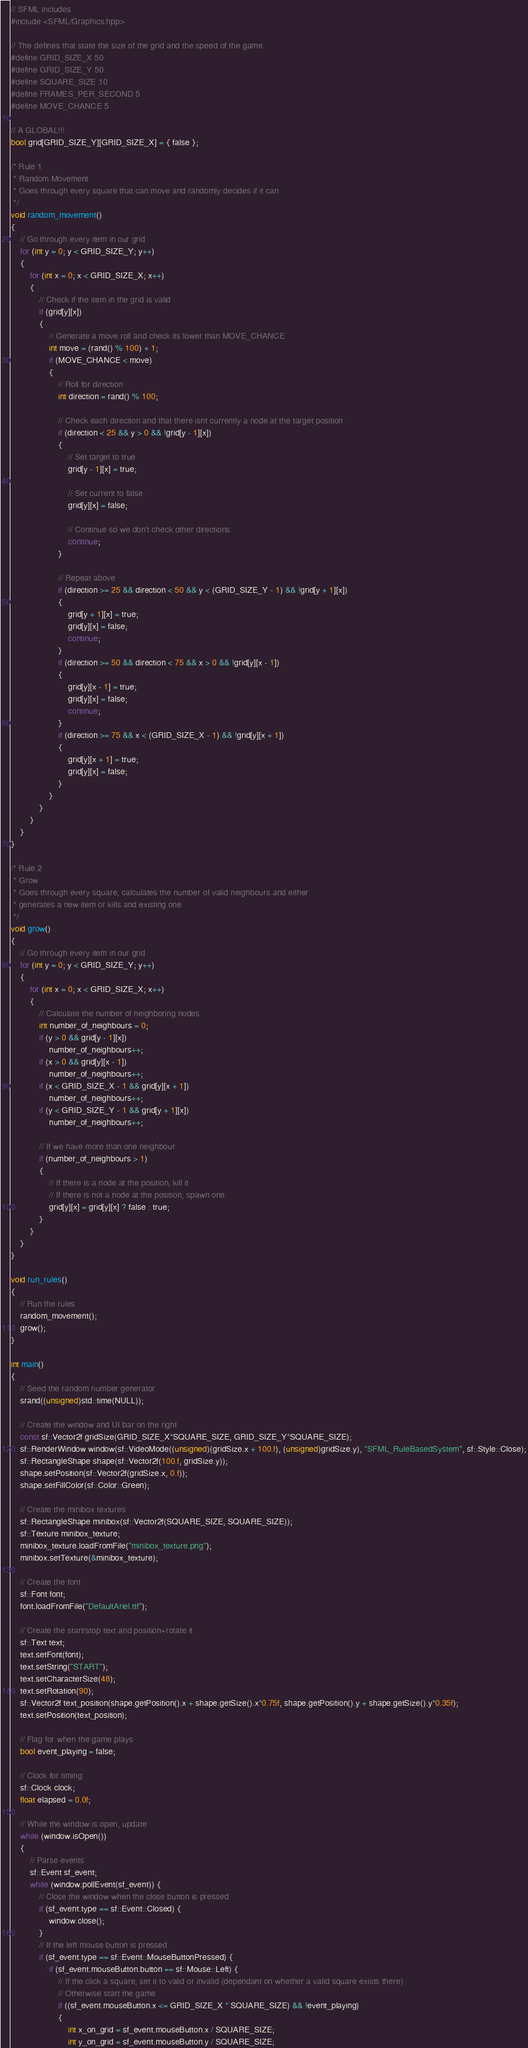Convert code to text. <code><loc_0><loc_0><loc_500><loc_500><_C++_>// SFML includes
#include <SFML/Graphics.hpp>

// The defines that state the size of the grid and the speed of the game.
#define GRID_SIZE_X 50
#define GRID_SIZE_Y 50
#define SQUARE_SIZE 10
#define FRAMES_PER_SECOND 5
#define MOVE_CHANCE 5

// A GLOBAL!!! 
bool grid[GRID_SIZE_Y][GRID_SIZE_X] = { false };

/* Rule 1
 * Random Movement
 * Goes through every square that can move and randomly decides if it can
 */
void random_movement()
{
	// Go through every item in our grid
	for (int y = 0; y < GRID_SIZE_Y; y++)
	{
		for (int x = 0; x < GRID_SIZE_X; x++)
		{
			// Check if the item in the grid is valid
			if (grid[y][x])
			{
				// Generate a move roll and check its lower than MOVE_CHANCE
				int move = (rand() % 100) + 1;
				if (MOVE_CHANCE < move)
				{
					// Roll for direction
					int direction = rand() % 100;

					// Check each direction and that there isnt currently a node at the target position
					if (direction < 25 && y > 0 && !grid[y - 1][x])
					{
						// Set target to true
						grid[y - 1][x] = true;

						// Set current to false
						grid[y][x] = false;

						// Continue so we don't check other directions
						continue;
					}

					// Repeat above
					if (direction >= 25 && direction < 50 && y < (GRID_SIZE_Y - 1) && !grid[y + 1][x])
					{
						grid[y + 1][x] = true;
						grid[y][x] = false;
						continue;
					}
					if (direction >= 50 && direction < 75 && x > 0 && !grid[y][x - 1])
					{
						grid[y][x - 1] = true;
						grid[y][x] = false;
						continue;
					}
					if (direction >= 75 && x < (GRID_SIZE_X - 1) && !grid[y][x + 1])
					{
						grid[y][x + 1] = true;
						grid[y][x] = false;
					}
				}
			}
		}
	}
}

/* Rule 2
 * Grow
 * Goes through every square, calculates the number of valid neighbours and either
 * generates a new item or kills and existing one
 */
void grow()
{
	// Go through every item in our grid
	for (int y = 0; y < GRID_SIZE_Y; y++)
	{
		for (int x = 0; x < GRID_SIZE_X; x++)
		{
			// Calculate the number of neighboring nodes
			int number_of_neighbours = 0;
			if (y > 0 && grid[y - 1][x])
				number_of_neighbours++;
			if (x > 0 && grid[y][x - 1])
				number_of_neighbours++;
			if (x < GRID_SIZE_X - 1 && grid[y][x + 1])
				number_of_neighbours++;
			if (y < GRID_SIZE_Y - 1 && grid[y + 1][x])
				number_of_neighbours++;

			// If we have more than one neighbour
			if (number_of_neighbours > 1)
			{
				// If there is a node at the position, kill it
				// If there is not a node at the position, spawn one
				grid[y][x] = grid[y][x] ? false : true;
			}
		}
	}
}

void run_rules()
{
	// Run the rules
	random_movement();
	grow();
}

int main()
{
	// Seed the random number generator
	srand((unsigned)std::time(NULL));

	// Create the window and UI bar on the right
	const sf::Vector2f gridSize(GRID_SIZE_X*SQUARE_SIZE, GRID_SIZE_Y*SQUARE_SIZE);
	sf::RenderWindow window(sf::VideoMode((unsigned)(gridSize.x + 100.f), (unsigned)gridSize.y), "SFML_RuleBasedSystem", sf::Style::Close);
	sf::RectangleShape shape(sf::Vector2f(100.f, gridSize.y));
	shape.setPosition(sf::Vector2f(gridSize.x, 0.f));
	shape.setFillColor(sf::Color::Green);

	// Create the minibox textures
	sf::RectangleShape minibox(sf::Vector2f(SQUARE_SIZE, SQUARE_SIZE));
	sf::Texture minibox_texture;
	minibox_texture.loadFromFile("minibox_texture.png");
	minibox.setTexture(&minibox_texture);

	// Create the font
	sf::Font font;
	font.loadFromFile("DefaultAriel.ttf");

	// Create the start/stop text and position+rotate it
	sf::Text text;
	text.setFont(font);
	text.setString("START");
	text.setCharacterSize(48);
	text.setRotation(90);
	sf::Vector2f text_position(shape.getPosition().x + shape.getSize().x*0.75f, shape.getPosition().y + shape.getSize().y*0.35f);
	text.setPosition(text_position);

	// Flag for when the game plays
	bool event_playing = false;

	// Clock for timing
	sf::Clock clock;
	float elapsed = 0.0f;

	// While the window is open, update
	while (window.isOpen())
	{
		// Parse events
		sf::Event sf_event;
		while (window.pollEvent(sf_event)) {
			// Close the window when the close button is pressed
			if (sf_event.type == sf::Event::Closed) {
				window.close();
			}
			// If the left mouse button is pressed
			if (sf_event.type == sf::Event::MouseButtonPressed) {
				if (sf_event.mouseButton.button == sf::Mouse::Left) {
					// If the click a square, set it to valid or invalid (dependant on whether a valid square exists there)
					// Otherwise start the game
					if ((sf_event.mouseButton.x <= GRID_SIZE_X * SQUARE_SIZE) && !event_playing)
					{
						int x_on_grid = sf_event.mouseButton.x / SQUARE_SIZE;
						int y_on_grid = sf_event.mouseButton.y / SQUARE_SIZE;</code> 